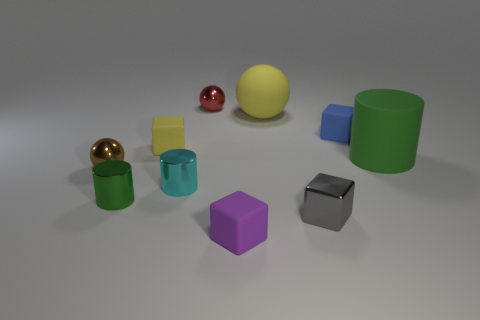Subtract all gray cubes. How many cubes are left? 3 Subtract all small metallic balls. How many balls are left? 1 Subtract 1 spheres. How many spheres are left? 2 Subtract all brown cubes. Subtract all red balls. How many cubes are left? 4 Subtract all cylinders. How many objects are left? 7 Subtract all small red shiny balls. Subtract all cyan cylinders. How many objects are left? 8 Add 2 gray shiny blocks. How many gray shiny blocks are left? 3 Add 7 purple blocks. How many purple blocks exist? 8 Subtract 1 yellow balls. How many objects are left? 9 